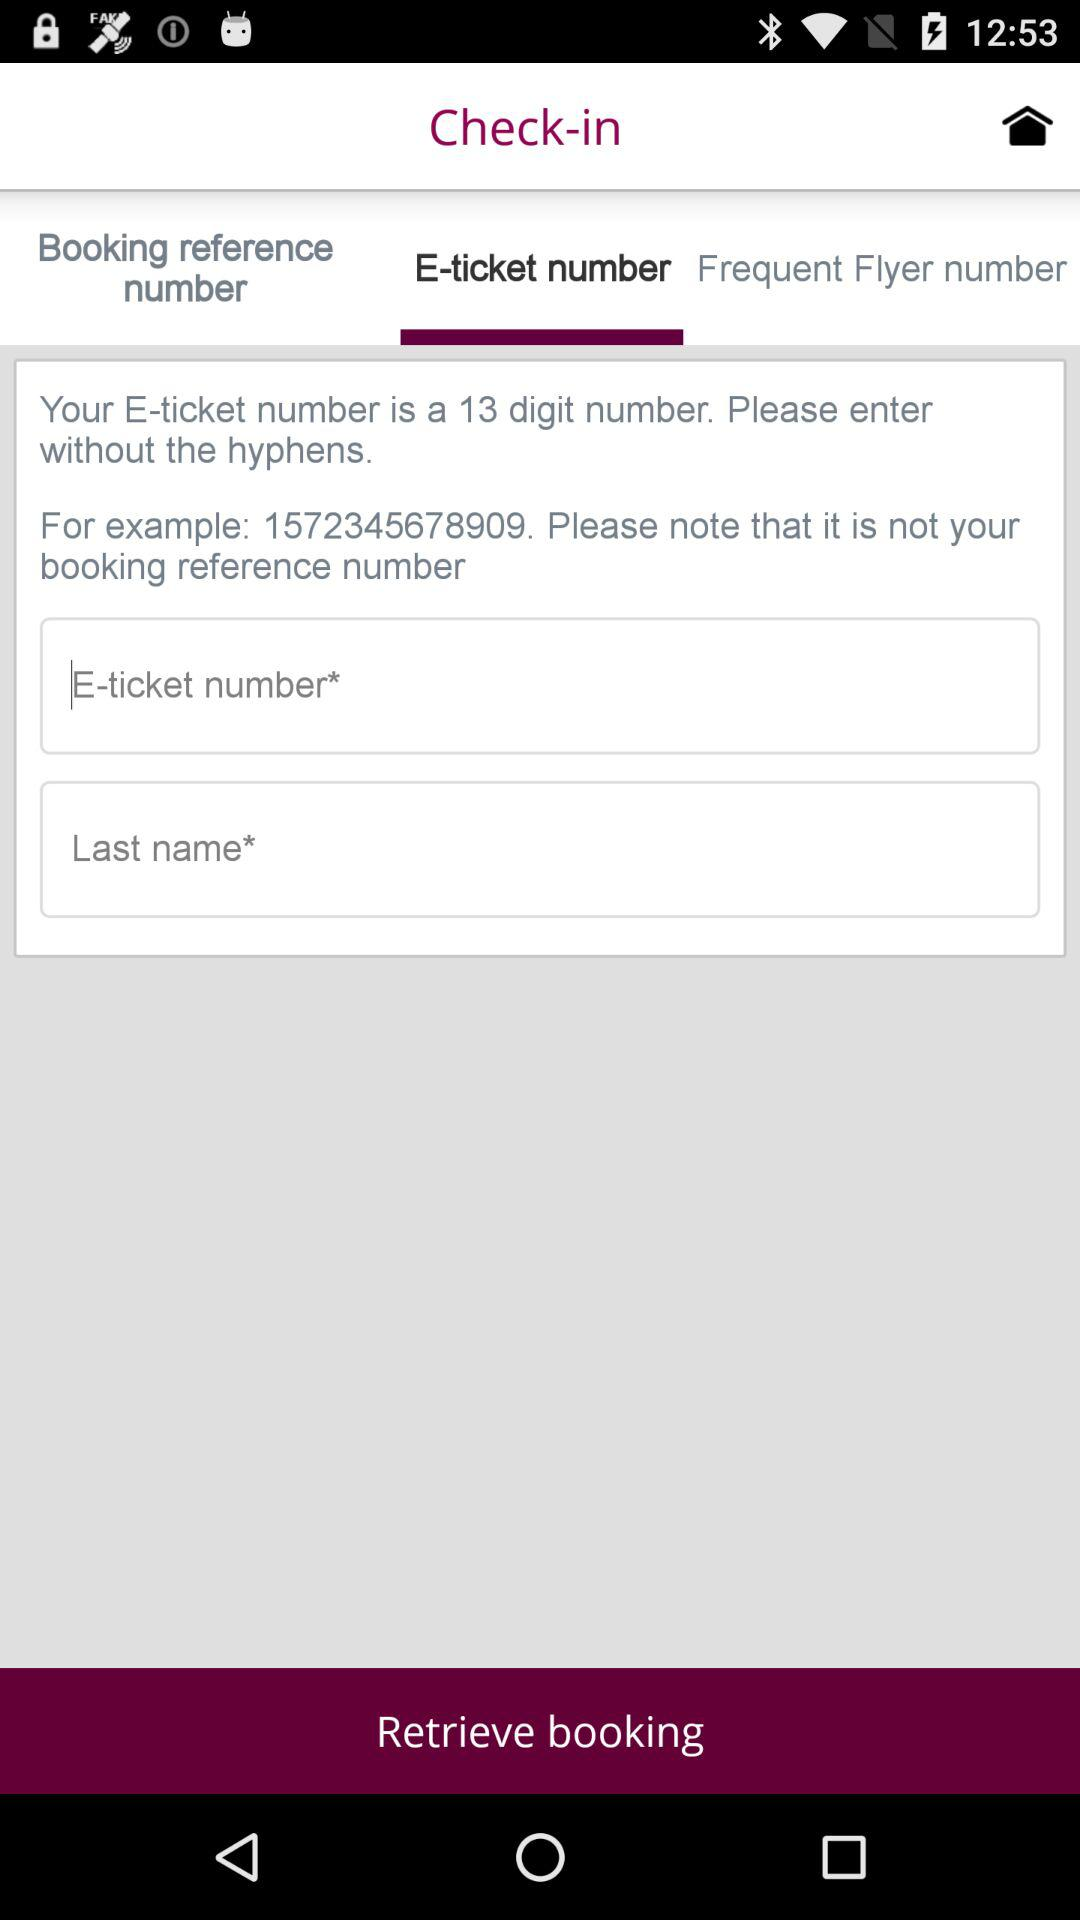How many digit numbers are available for "E-ticket number"? There are 13 digit numbers available. 